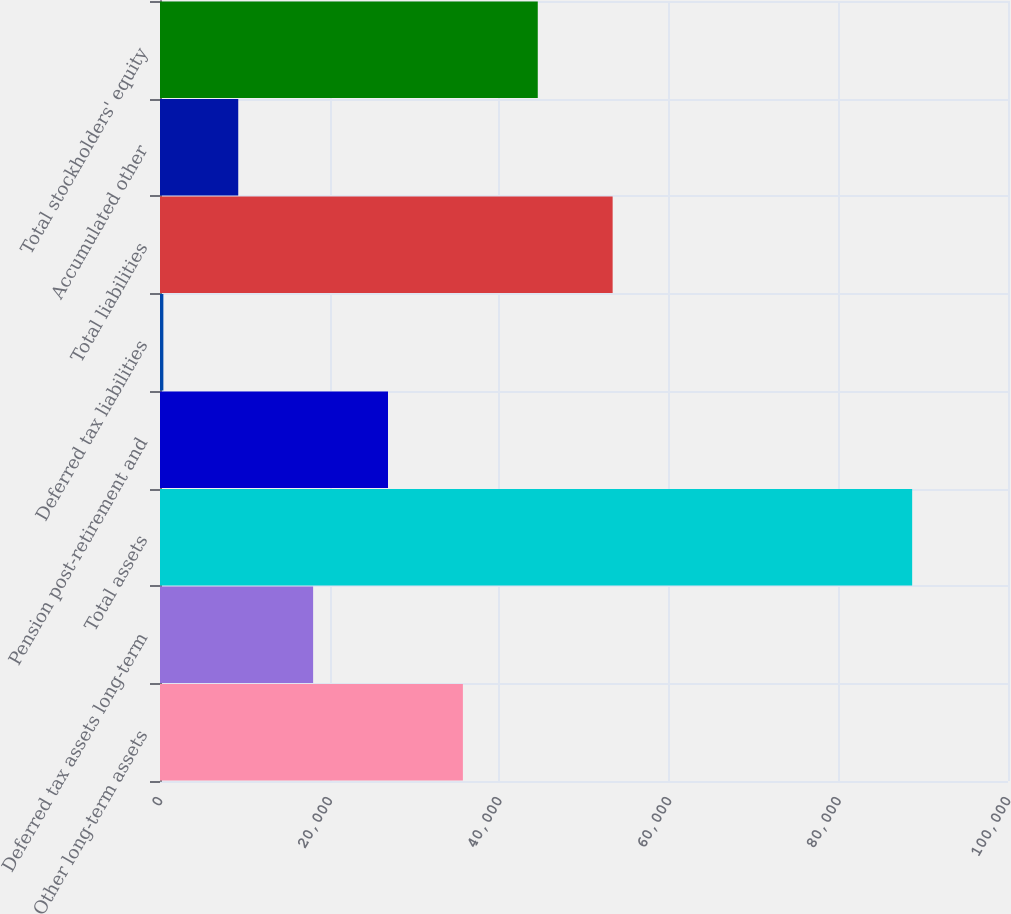Convert chart. <chart><loc_0><loc_0><loc_500><loc_500><bar_chart><fcel>Other long-term assets<fcel>Deferred tax assets long-term<fcel>Total assets<fcel>Pension post-retirement and<fcel>Deferred tax liabilities<fcel>Total liabilities<fcel>Accumulated other<fcel>Total stockholders' equity<nl><fcel>35717.8<fcel>18057.4<fcel>88699<fcel>26887.6<fcel>397<fcel>53378.2<fcel>9227.2<fcel>44548<nl></chart> 